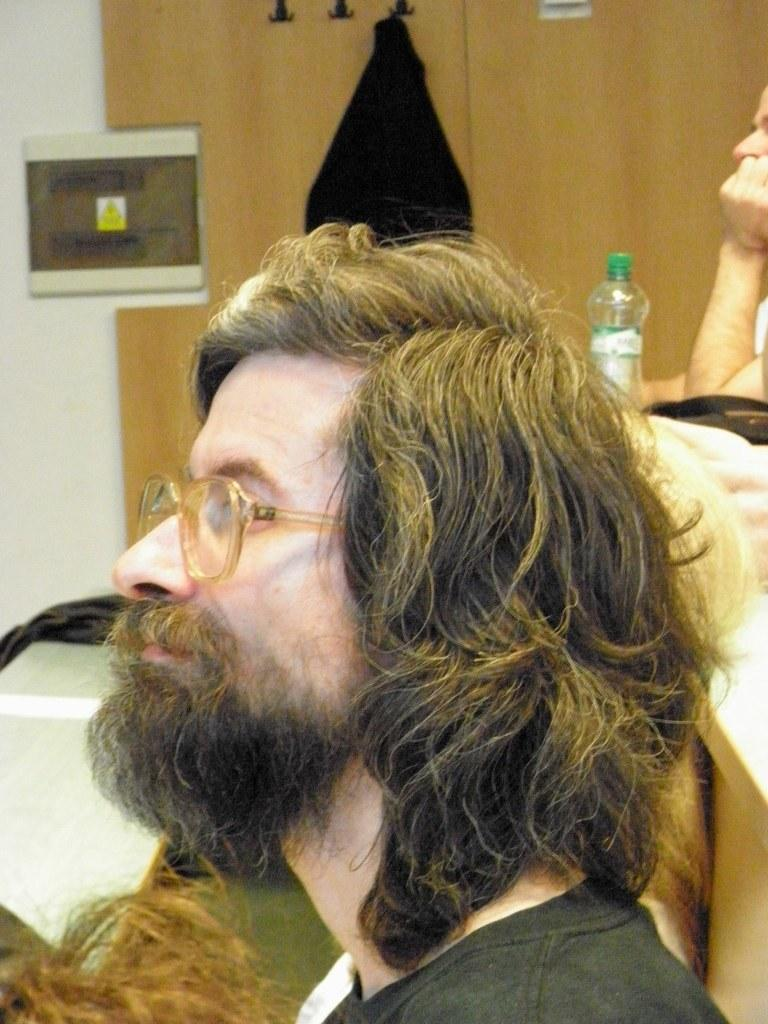Who is present in the image? There is a man in the image. What object can be seen near the man? There is a glass bottle in the image. What type of furniture is visible in the image? There is a cupboard in the image. What type of corn can be seen growing on the cupboard in the image? There is no corn visible in the image, and the cupboard is not a place where corn would typically grow. 